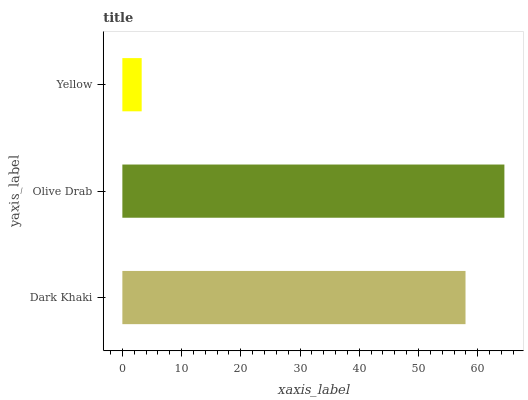Is Yellow the minimum?
Answer yes or no. Yes. Is Olive Drab the maximum?
Answer yes or no. Yes. Is Olive Drab the minimum?
Answer yes or no. No. Is Yellow the maximum?
Answer yes or no. No. Is Olive Drab greater than Yellow?
Answer yes or no. Yes. Is Yellow less than Olive Drab?
Answer yes or no. Yes. Is Yellow greater than Olive Drab?
Answer yes or no. No. Is Olive Drab less than Yellow?
Answer yes or no. No. Is Dark Khaki the high median?
Answer yes or no. Yes. Is Dark Khaki the low median?
Answer yes or no. Yes. Is Olive Drab the high median?
Answer yes or no. No. Is Yellow the low median?
Answer yes or no. No. 